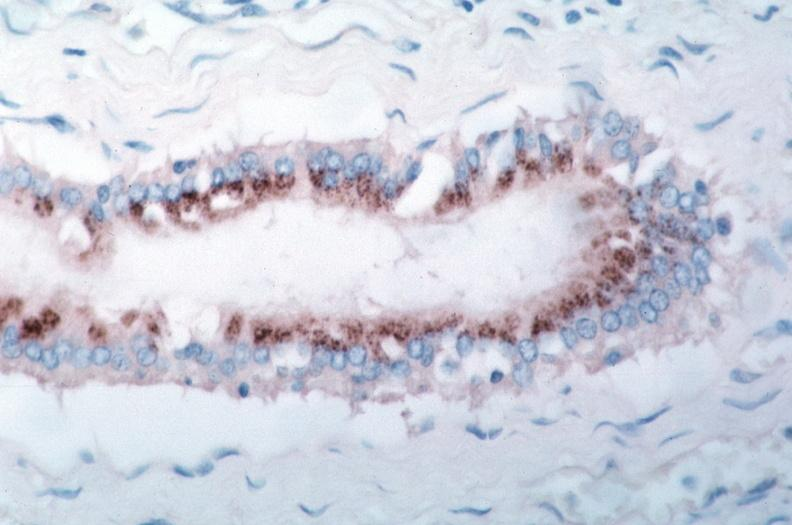what spotted fever, immunoperoxidase staining vessels for rickettsia rickettsii?
Answer the question using a single word or phrase. Rocky mountain 